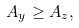Convert formula to latex. <formula><loc_0><loc_0><loc_500><loc_500>A _ { y } \geq A _ { z } ,</formula> 